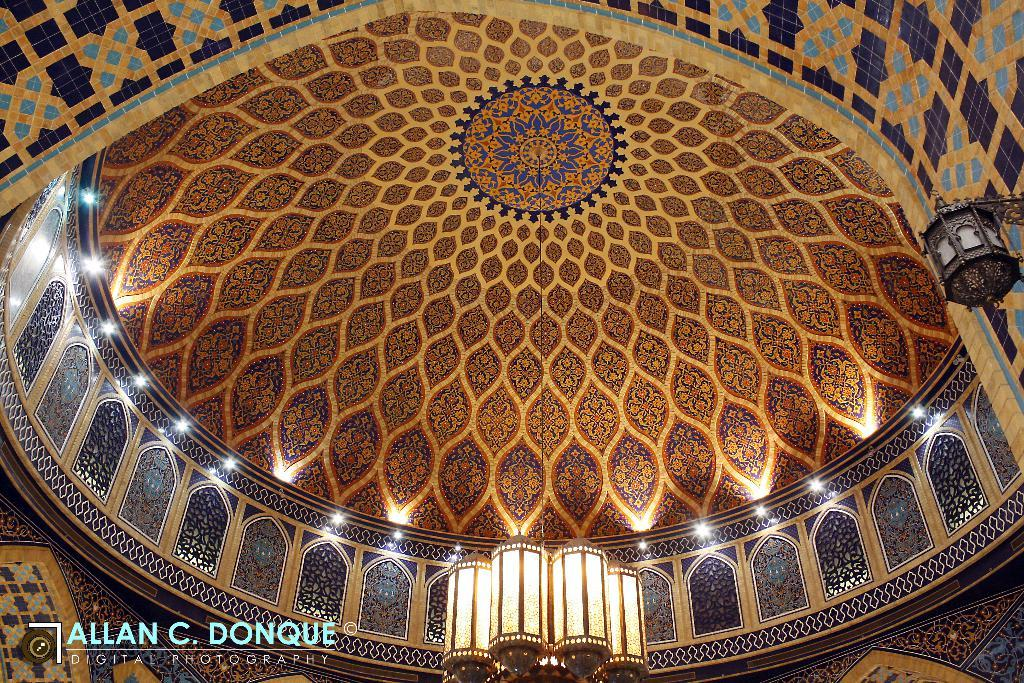What can be seen in the bottom left corner of the image? There is a watermark in the bottom left of the image. What is hanging in the background of the image? There is a light attached to a thread in the background of the image. How is the light connected to the roof? The light is connected to the roof. Are there any other lights visible in the image? Yes, there are additional lights attached to the roof. What type of agreement is being signed in the image? There is no indication of an agreement or signing in the image; it primarily features lights and a watermark. Can you see a pancake on the roof in the image? There is no pancake present in the image. 